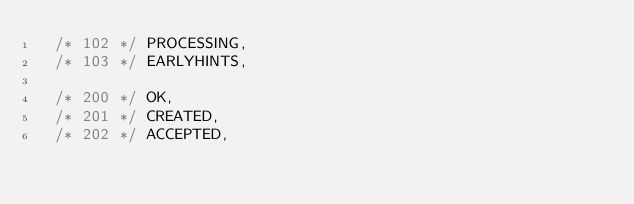<code> <loc_0><loc_0><loc_500><loc_500><_Scala_>  /* 102 */ PROCESSING,
  /* 103 */ EARLYHINTS,

  /* 200 */ OK,
  /* 201 */ CREATED,
  /* 202 */ ACCEPTED,</code> 